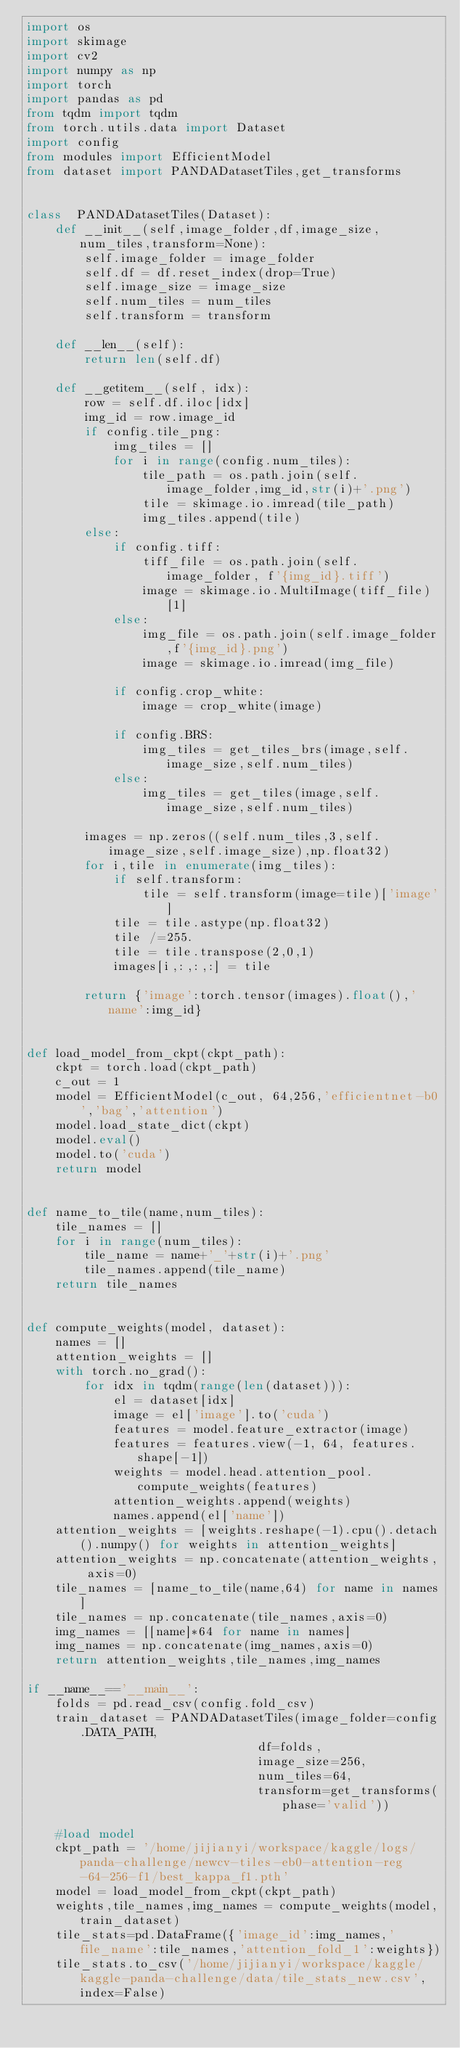<code> <loc_0><loc_0><loc_500><loc_500><_Python_>import os 
import skimage
import cv2 
import numpy as np 
import torch 
import pandas as pd 
from tqdm import tqdm
from torch.utils.data import Dataset
import config
from modules import EfficientModel
from dataset import PANDADatasetTiles,get_transforms


class  PANDADatasetTiles(Dataset):
    def __init__(self,image_folder,df,image_size,num_tiles,transform=None):
        self.image_folder = image_folder
        self.df = df.reset_index(drop=True)
        self.image_size = image_size 
        self.num_tiles = num_tiles
        self.transform = transform
        
    def __len__(self):
        return len(self.df)

    def __getitem__(self, idx):
        row = self.df.iloc[idx]
        img_id = row.image_id
        if config.tile_png:
            img_tiles = []
            for i in range(config.num_tiles):
                tile_path = os.path.join(self.image_folder,img_id,str(i)+'.png')
                tile = skimage.io.imread(tile_path)
                img_tiles.append(tile)
        else:
            if config.tiff:
                tiff_file = os.path.join(self.image_folder, f'{img_id}.tiff')
                image = skimage.io.MultiImage(tiff_file)[1]
            else:
                img_file = os.path.join(self.image_folder,f'{img_id}.png')
                image = skimage.io.imread(img_file)
                
            if config.crop_white:
                image = crop_white(image)

            if config.BRS:  
                img_tiles = get_tiles_brs(image,self.image_size,self.num_tiles)
            else:
                img_tiles = get_tiles(image,self.image_size,self.num_tiles)

        images = np.zeros((self.num_tiles,3,self.image_size,self.image_size),np.float32)
        for i,tile in enumerate(img_tiles):
            if self.transform:
                tile = self.transform(image=tile)['image']
            tile = tile.astype(np.float32)
            tile /=255. 
            tile = tile.transpose(2,0,1)
            images[i,:,:,:] = tile 

        return {'image':torch.tensor(images).float(),'name':img_id}


def load_model_from_ckpt(ckpt_path):
    ckpt = torch.load(ckpt_path)
    c_out = 1 
    model = EfficientModel(c_out, 64,256,'efficientnet-b0','bag','attention')
    model.load_state_dict(ckpt)
    model.eval()
    model.to('cuda')
    return model


def name_to_tile(name,num_tiles):
    tile_names = []
    for i in range(num_tiles):
        tile_name = name+'_'+str(i)+'.png'
        tile_names.append(tile_name)
    return tile_names


def compute_weights(model, dataset):
    names = []
    attention_weights = []
    with torch.no_grad():
        for idx in tqdm(range(len(dataset))):
            el = dataset[idx]
            image = el['image'].to('cuda')
            features = model.feature_extractor(image)
            features = features.view(-1, 64, features.shape[-1])
            weights = model.head.attention_pool.compute_weights(features)
            attention_weights.append(weights)
            names.append(el['name'])
    attention_weights = [weights.reshape(-1).cpu().detach().numpy() for weights in attention_weights]
    attention_weights = np.concatenate(attention_weights, axis=0)
    tile_names = [name_to_tile(name,64) for name in names]
    tile_names = np.concatenate(tile_names,axis=0) 
    img_names = [[name]*64 for name in names]
    img_names = np.concatenate(img_names,axis=0)
    return attention_weights,tile_names,img_names

if __name__=='__main__':
    folds = pd.read_csv(config.fold_csv)
    train_dataset = PANDADatasetTiles(image_folder=config.DATA_PATH,
                                df=folds,
                                image_size=256,
                                num_tiles=64,
                                transform=get_transforms(phase='valid'))
    
    #load model 
    ckpt_path = '/home/jijianyi/workspace/kaggle/logs/panda-challenge/newcv-tiles-eb0-attention-reg-64-256-f1/best_kappa_f1.pth'
    model = load_model_from_ckpt(ckpt_path)
    weights,tile_names,img_names = compute_weights(model,train_dataset)
    tile_stats=pd.DataFrame({'image_id':img_names,'file_name':tile_names,'attention_fold_1':weights})
    tile_stats.to_csv('/home/jijianyi/workspace/kaggle/kaggle-panda-challenge/data/tile_stats_new.csv',index=False)

    

</code> 